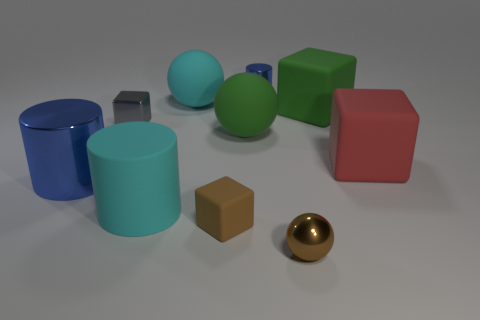Does the tiny gray metal object have the same shape as the blue thing that is to the left of the brown rubber object?
Give a very brief answer. No. There is a blue thing that is to the right of the cyan cylinder; does it have the same size as the red block?
Ensure brevity in your answer.  No. The red rubber object that is the same size as the cyan matte sphere is what shape?
Offer a very short reply. Cube. Does the tiny gray object have the same shape as the big metal object?
Ensure brevity in your answer.  No. What number of other large red objects are the same shape as the large red thing?
Keep it short and to the point. 0. There is a tiny cylinder; what number of big red matte blocks are behind it?
Your answer should be compact. 0. There is a shiny cylinder that is behind the big red block; does it have the same color as the small shiny block?
Ensure brevity in your answer.  No. What number of gray shiny things have the same size as the metallic cube?
Your response must be concise. 0. What shape is the big cyan thing that is made of the same material as the big cyan ball?
Provide a short and direct response. Cylinder. Are there any other blocks that have the same color as the tiny metal cube?
Provide a short and direct response. No. 